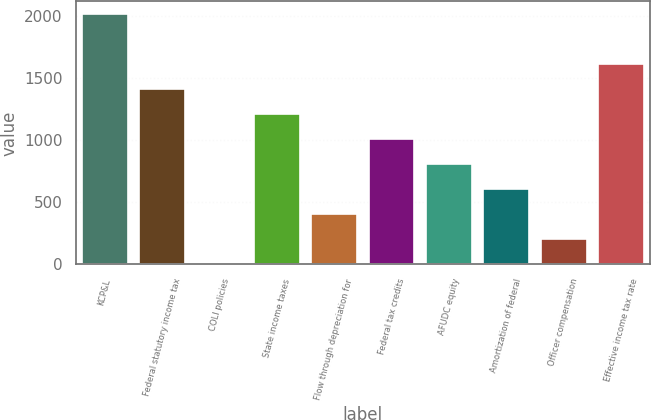Convert chart to OTSL. <chart><loc_0><loc_0><loc_500><loc_500><bar_chart><fcel>KCP&L<fcel>Federal statutory income tax<fcel>COLI policies<fcel>State income taxes<fcel>Flow through depreciation for<fcel>Federal tax credits<fcel>AFUDC equity<fcel>Amortization of federal<fcel>Officer compensation<fcel>Effective income tax rate<nl><fcel>2016<fcel>1411.26<fcel>0.2<fcel>1209.68<fcel>403.36<fcel>1008.1<fcel>806.52<fcel>604.94<fcel>201.78<fcel>1612.84<nl></chart> 